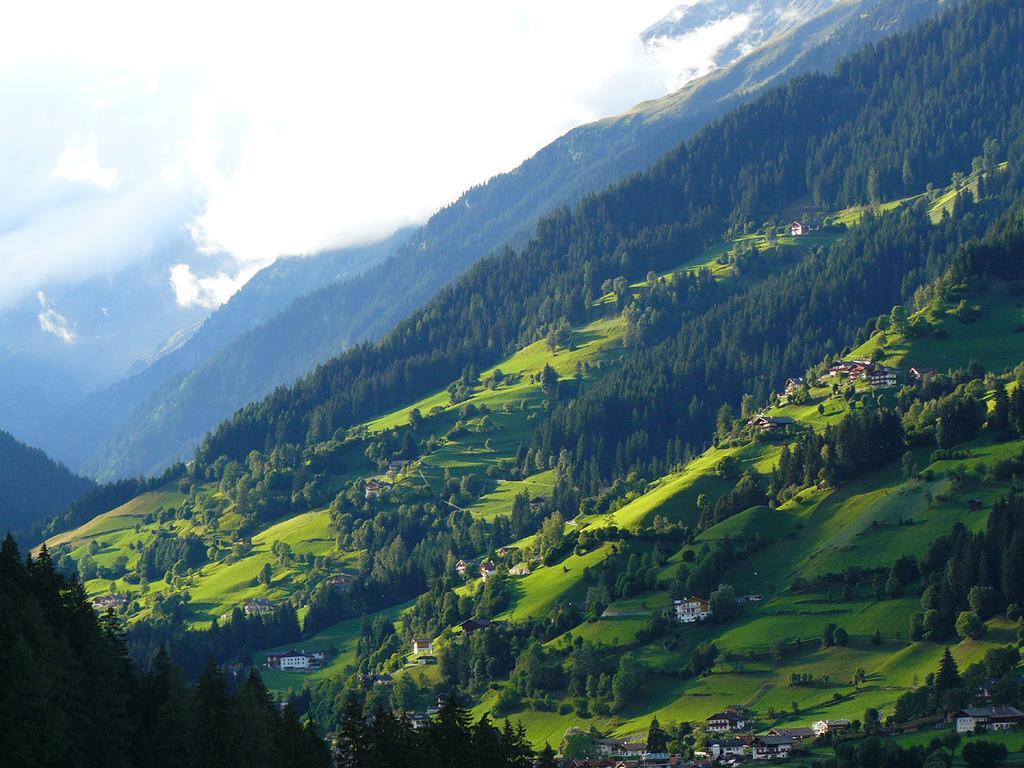Describe this image in one or two sentences. In this picture we can see houses, trees, mountains and in the background we can see the sky with clouds. 